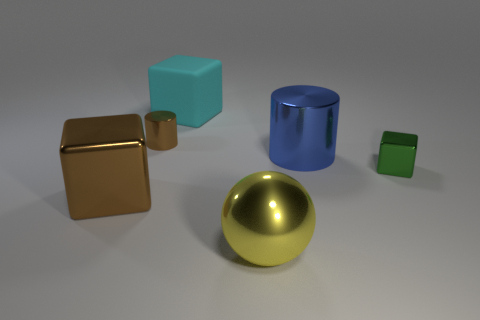What number of metal objects are both in front of the green block and on the left side of the large shiny ball?
Make the answer very short. 1. Is the size of the brown metallic object that is in front of the blue object the same as the brown object that is behind the tiny green thing?
Provide a short and direct response. No. What size is the cube that is behind the small green metal cube?
Offer a terse response. Large. How many things are large objects to the left of the blue metal cylinder or cubes that are right of the big yellow shiny ball?
Make the answer very short. 4. Is there any other thing that has the same color as the big cylinder?
Keep it short and to the point. No. Are there an equal number of green metallic objects behind the big cyan rubber block and tiny metallic cylinders that are on the left side of the brown block?
Keep it short and to the point. Yes. Is the number of cylinders behind the cyan object greater than the number of tiny green rubber spheres?
Your answer should be compact. No. How many objects are cylinders behind the blue metallic cylinder or yellow balls?
Offer a terse response. 2. How many blocks have the same material as the large cylinder?
Provide a short and direct response. 2. There is a big thing that is the same color as the tiny metallic cylinder; what is its shape?
Offer a very short reply. Cube. 